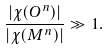Convert formula to latex. <formula><loc_0><loc_0><loc_500><loc_500>\frac { | \chi ( O ^ { n } ) | } { | \chi ( M ^ { n } ) | } & \gg 1 .</formula> 